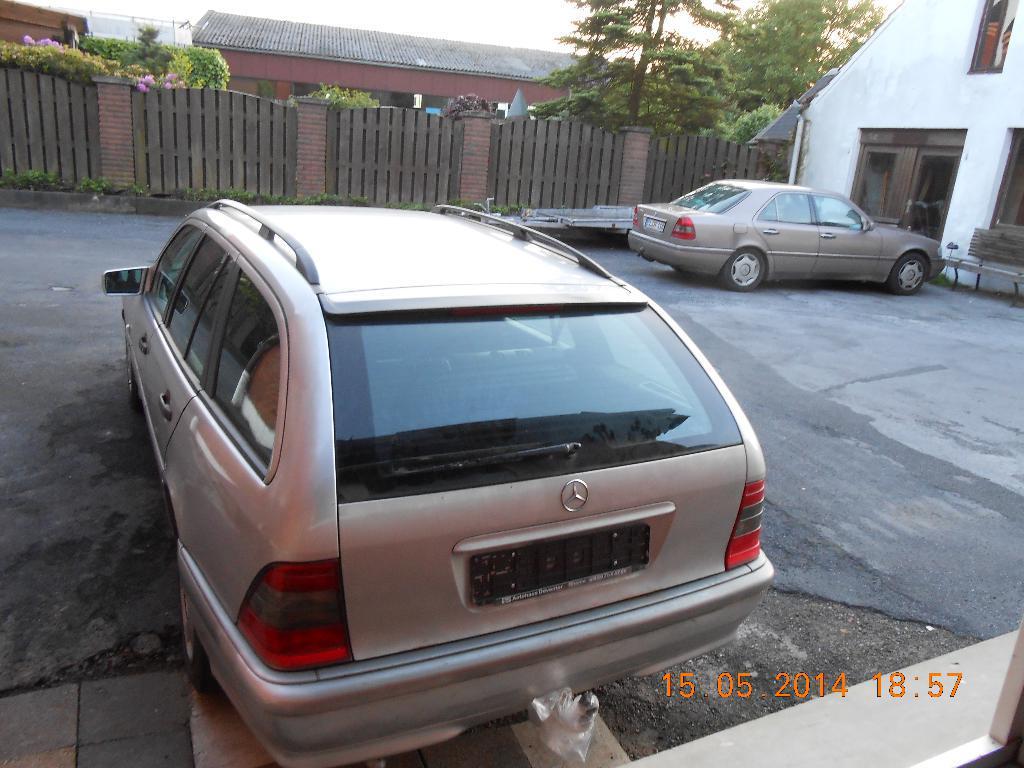Could you give a brief overview of what you see in this image? In this picture there are two cars which are the parked near to the buildings. In the back I can see the wooden partition, plants, trees, shed, advertisement board and other objects. At the top I can see the sky. In the bottom right corner there is a watermark. 